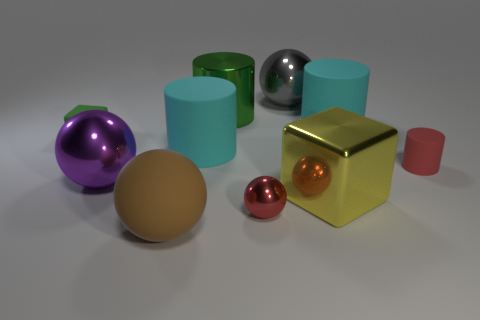Do the small metal sphere and the tiny cylinder have the same color?
Your response must be concise. Yes. What size is the cylinder that is the same color as the small metallic sphere?
Give a very brief answer. Small. Is the number of big green things in front of the small red cylinder the same as the number of big balls?
Your response must be concise. No. There is a large green cylinder that is to the left of the large ball behind the tiny red rubber cylinder; what is its material?
Provide a short and direct response. Metal. What is the shape of the small red rubber object?
Keep it short and to the point. Cylinder. Are there an equal number of tiny rubber objects that are on the left side of the small red rubber object and cyan objects on the right side of the green cylinder?
Make the answer very short. Yes. There is a tiny object that is on the left side of the big purple ball; is its color the same as the small rubber object that is on the right side of the matte block?
Ensure brevity in your answer.  No. Are there more matte objects left of the big yellow metal object than big metal blocks?
Provide a succinct answer. Yes. What is the shape of the green object that is made of the same material as the red cylinder?
Provide a succinct answer. Cube. Is the size of the red thing to the left of the yellow object the same as the purple metallic thing?
Make the answer very short. No. 